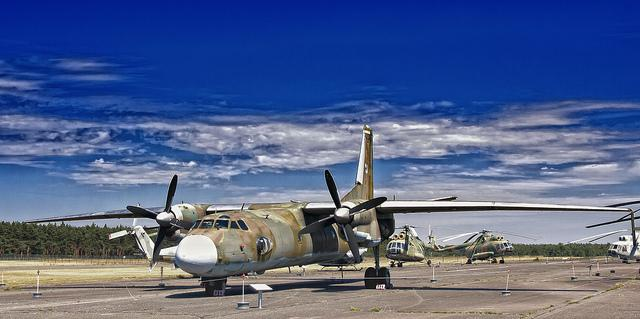What are the four things on each side of the vehicle called? propellers 